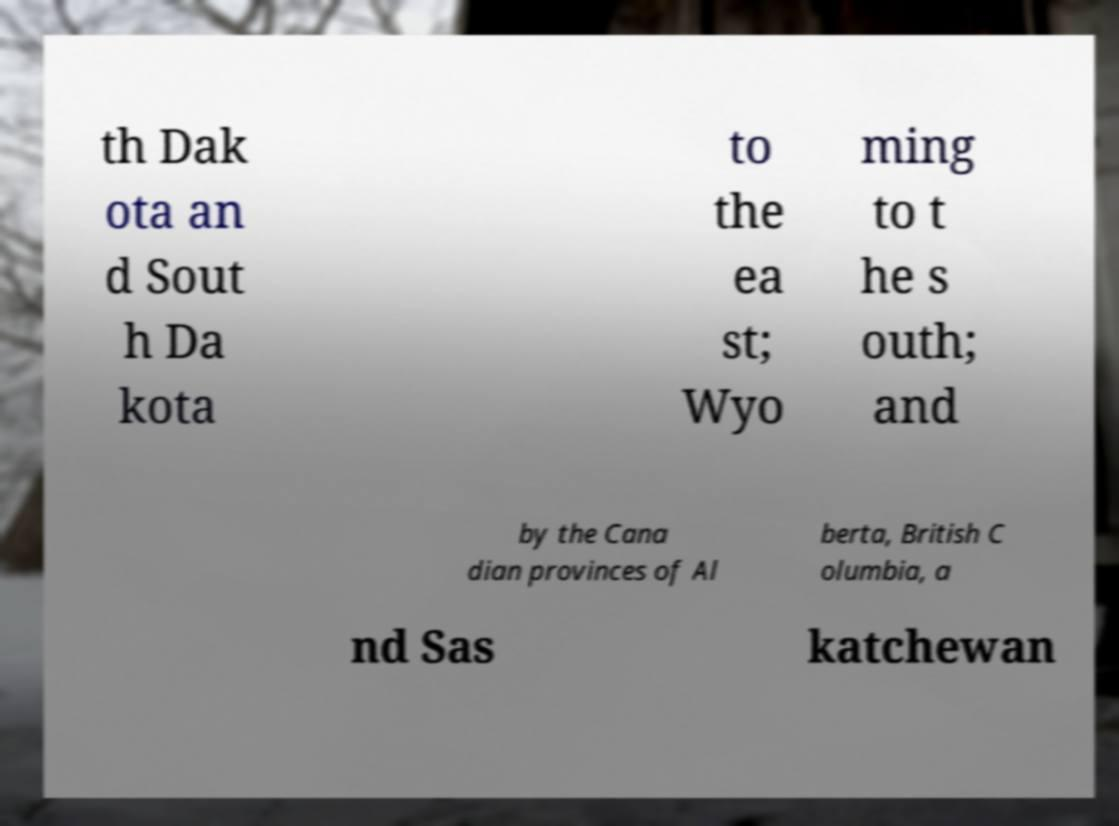For documentation purposes, I need the text within this image transcribed. Could you provide that? th Dak ota an d Sout h Da kota to the ea st; Wyo ming to t he s outh; and by the Cana dian provinces of Al berta, British C olumbia, a nd Sas katchewan 